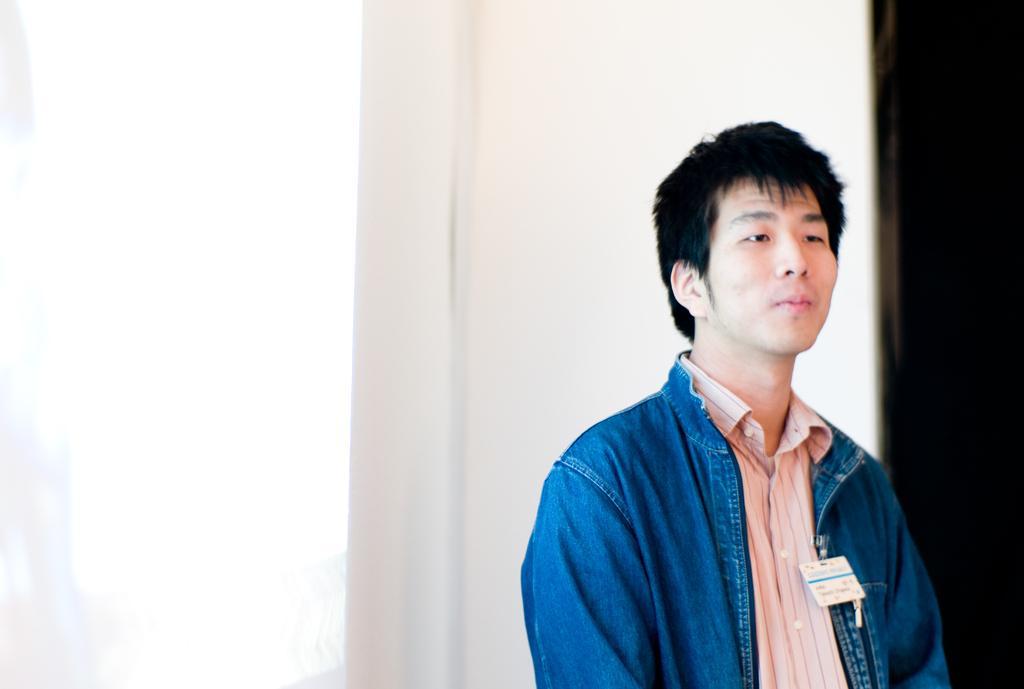Can you describe this image briefly? In this picture I can see a man who is standing in front and I see that he is wearing a jacket and a shirt and I see the white and black color background. 